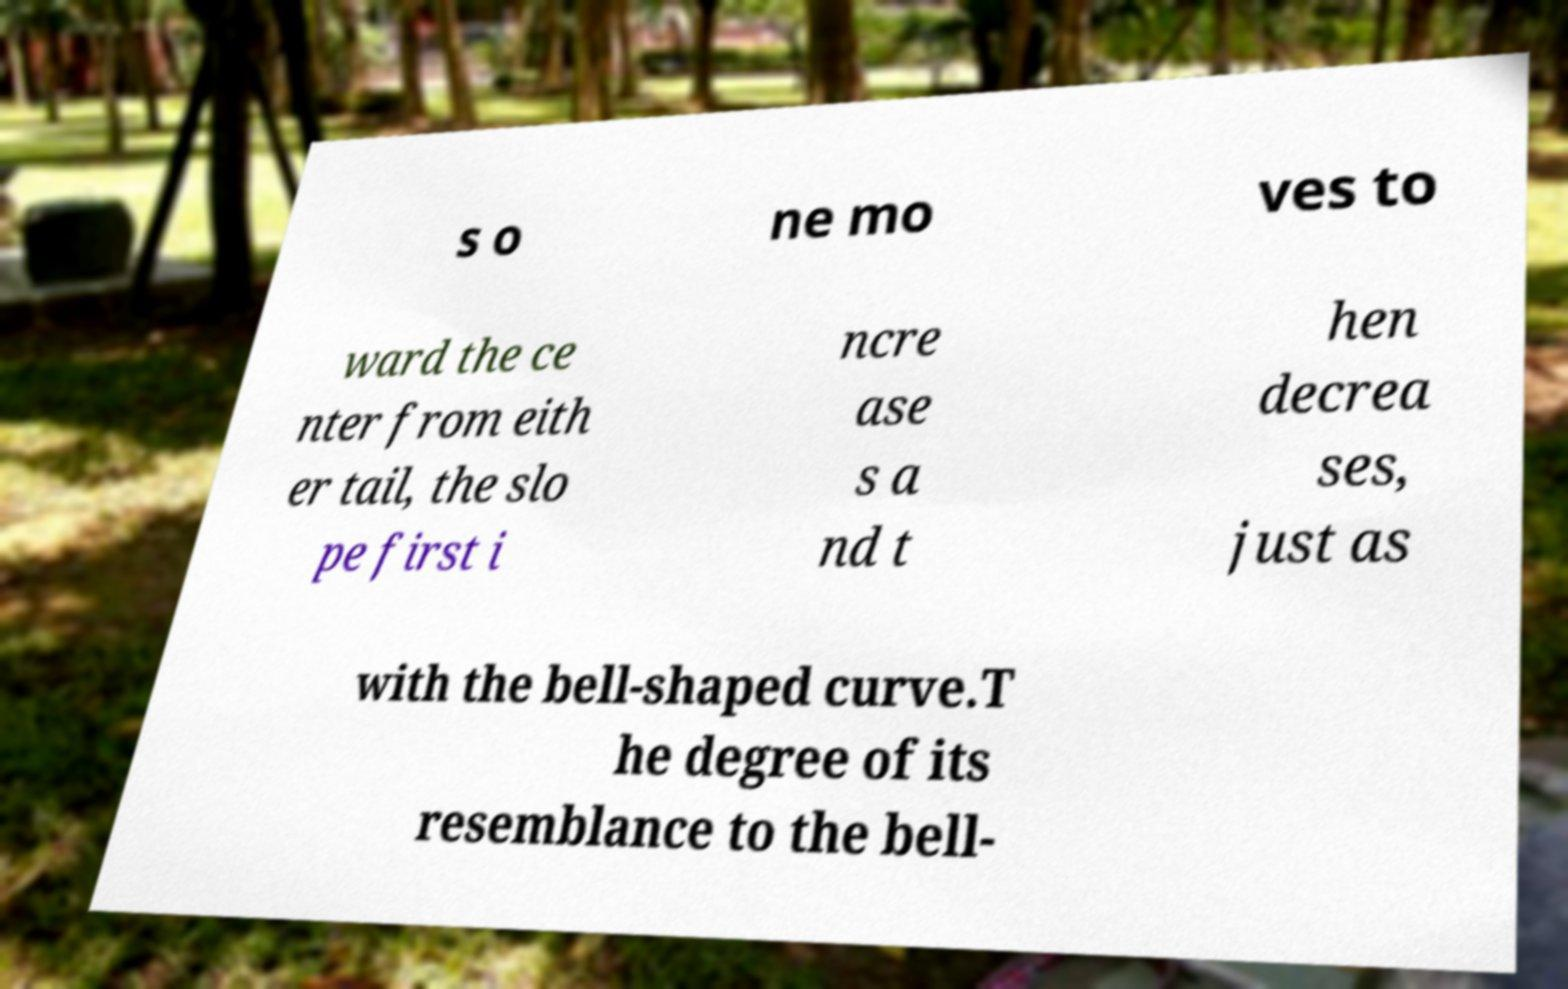Please read and relay the text visible in this image. What does it say? s o ne mo ves to ward the ce nter from eith er tail, the slo pe first i ncre ase s a nd t hen decrea ses, just as with the bell-shaped curve.T he degree of its resemblance to the bell- 